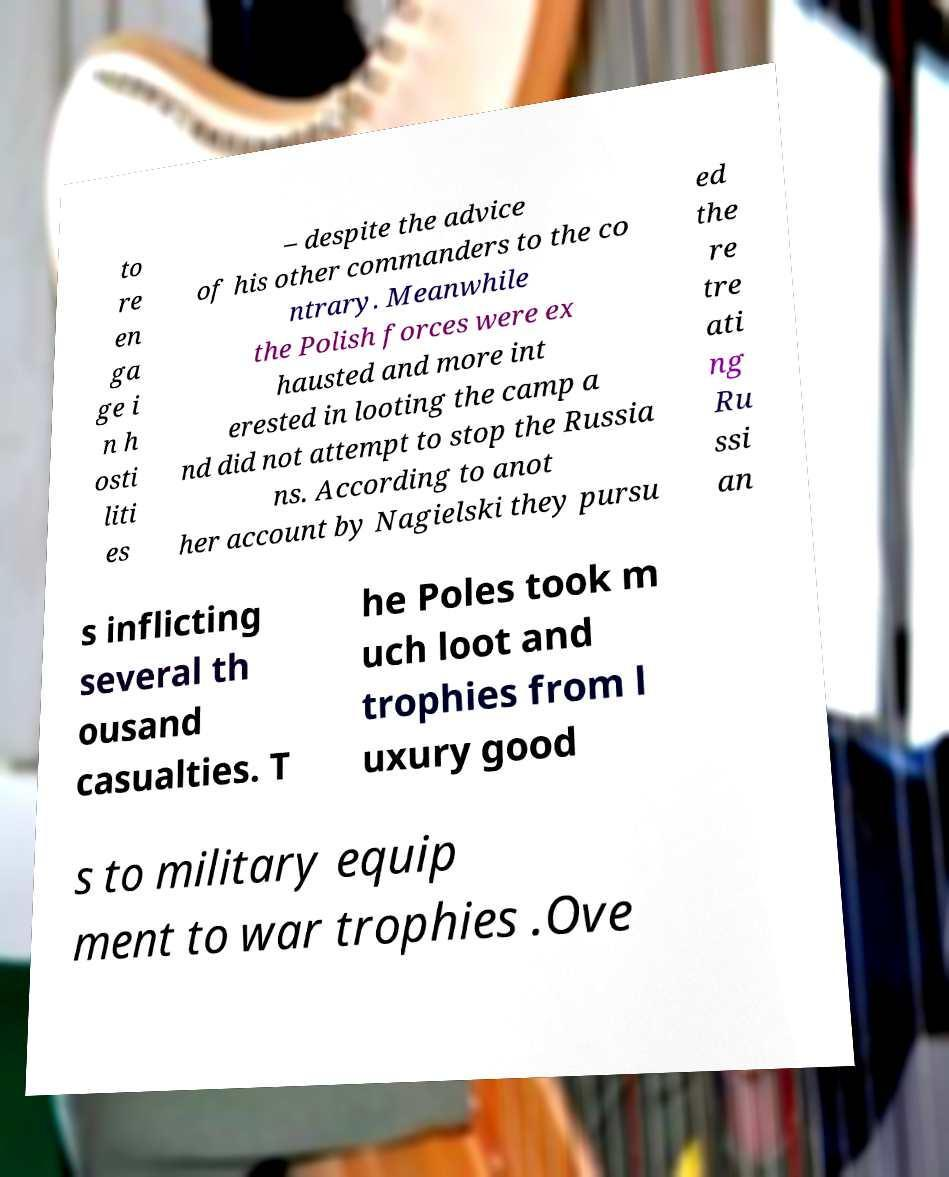Could you assist in decoding the text presented in this image and type it out clearly? to re en ga ge i n h osti liti es – despite the advice of his other commanders to the co ntrary. Meanwhile the Polish forces were ex hausted and more int erested in looting the camp a nd did not attempt to stop the Russia ns. According to anot her account by Nagielski they pursu ed the re tre ati ng Ru ssi an s inflicting several th ousand casualties. T he Poles took m uch loot and trophies from l uxury good s to military equip ment to war trophies .Ove 